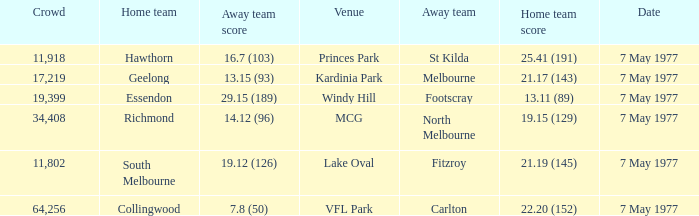Name the home team score for larger crowd than 11,918 for windy hill venue 13.11 (89). Give me the full table as a dictionary. {'header': ['Crowd', 'Home team', 'Away team score', 'Venue', 'Away team', 'Home team score', 'Date'], 'rows': [['11,918', 'Hawthorn', '16.7 (103)', 'Princes Park', 'St Kilda', '25.41 (191)', '7 May 1977'], ['17,219', 'Geelong', '13.15 (93)', 'Kardinia Park', 'Melbourne', '21.17 (143)', '7 May 1977'], ['19,399', 'Essendon', '29.15 (189)', 'Windy Hill', 'Footscray', '13.11 (89)', '7 May 1977'], ['34,408', 'Richmond', '14.12 (96)', 'MCG', 'North Melbourne', '19.15 (129)', '7 May 1977'], ['11,802', 'South Melbourne', '19.12 (126)', 'Lake Oval', 'Fitzroy', '21.19 (145)', '7 May 1977'], ['64,256', 'Collingwood', '7.8 (50)', 'VFL Park', 'Carlton', '22.20 (152)', '7 May 1977']]} 